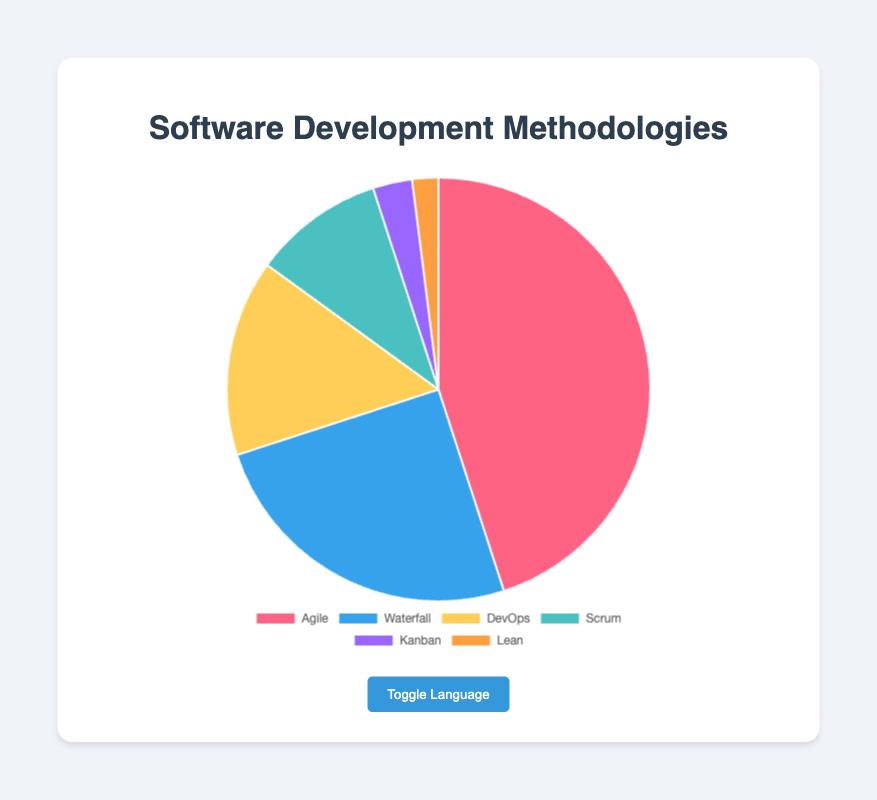What is the most commonly adopted methodology? The pie chart shows different methodologies with their respective percentages. The most commonly adopted methodology has the highest percentage, which is Agile at 45%.
Answer: Agile What is the least adopted software development methodology? By referring to the pie chart, the methodology with the smallest percentage is the least adopted one. Lean has the smallest percentage at 2%.
Answer: Lean What is the combined percentage of Agile and Waterfall methodologies? Add the percentages of Agile and Waterfall: Agile (45%) + Waterfall (25%) = 70%.
Answer: 70% Which methodology is adopted more frequently, DevOps or Scrum? Compare the percentages of DevOps (15%) and Scrum (10%). DevOps has a higher percentage than Scrum.
Answer: DevOps By how much does the adoption of Agile methodology exceed that of Kanban? Subtract the percentage of Kanban (3%) from the percentage of Agile (45%): 45% - 3% = 42%.
Answer: 42% What percentage do Kanban and Lean methodologies together represent? Add the percentages of Kanban (3%) and Lean (2%): 3% + 2% = 5%.
Answer: 5% How many times more is Agile adopted than Lean? Divide the percentage of Agile (45%) by the percentage of Lean (2%): 45 / 2 = 22.5 times.
Answer: 22.5 times Which methodology comes third in terms of adoption rate? In the pie chart, the methodology with the third highest percentage is DevOps at 15%.
Answer: DevOps What is the difference in adoption rates between the methodologies with the highest and lowest percentages? Subtract the percentage of Lean (2%) from the percentage of Agile (45%): 45% - 2% = 43%.
Answer: 43% What's the total percentage of methodologies other than Agile and Waterfall? Subtract the combined percentage of Agile (45%) and Waterfall (25%) from 100%: 100% - (45% + 25%) = 100% - 70% = 30%.
Answer: 30% 